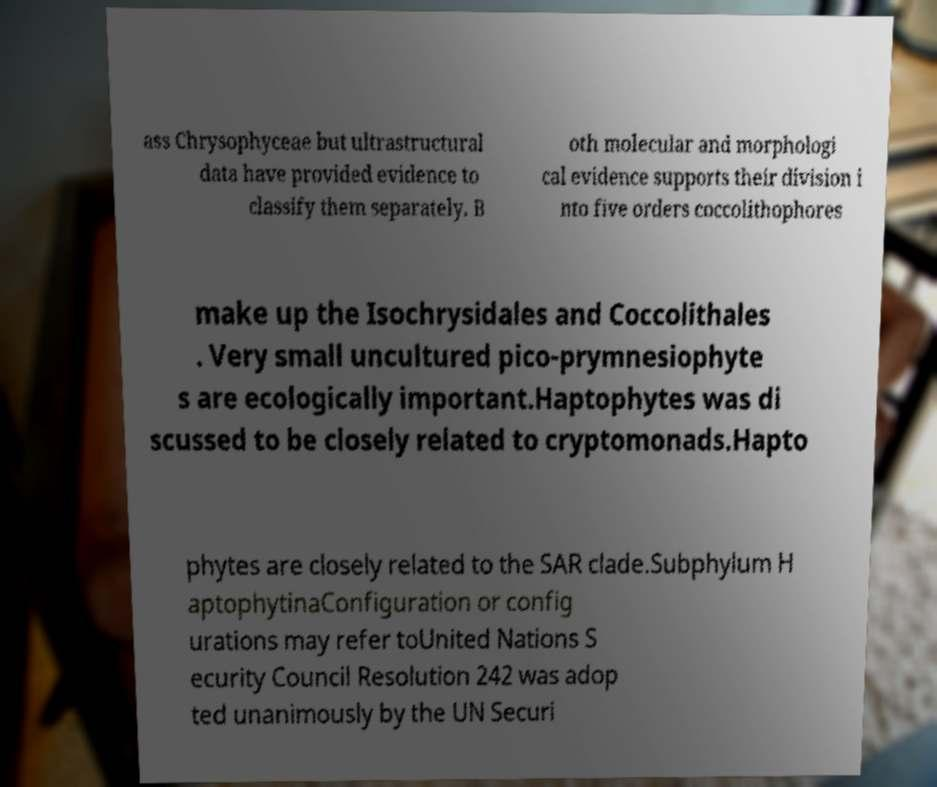Could you assist in decoding the text presented in this image and type it out clearly? ass Chrysophyceae but ultrastructural data have provided evidence to classify them separately. B oth molecular and morphologi cal evidence supports their division i nto five orders coccolithophores make up the Isochrysidales and Coccolithales . Very small uncultured pico-prymnesiophyte s are ecologically important.Haptophytes was di scussed to be closely related to cryptomonads.Hapto phytes are closely related to the SAR clade.Subphylum H aptophytinaConfiguration or config urations may refer toUnited Nations S ecurity Council Resolution 242 was adop ted unanimously by the UN Securi 